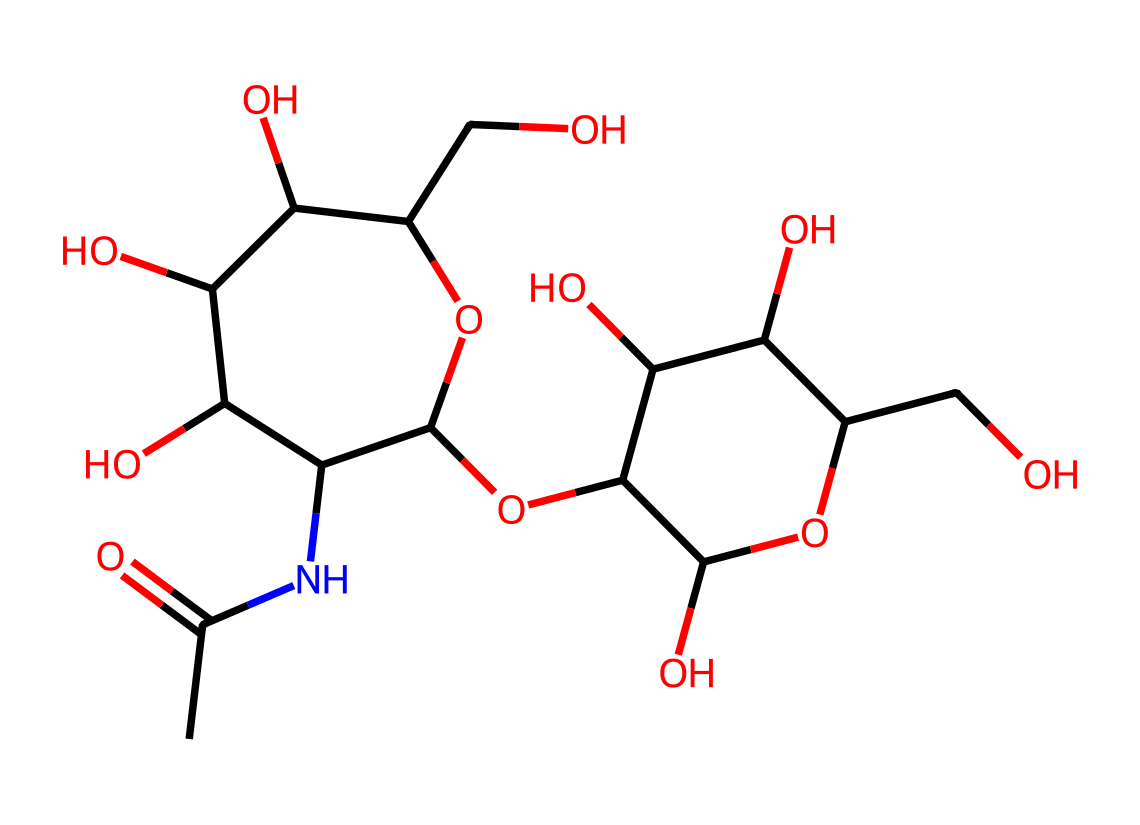What is the molecular formula of hyaluronic acid? To determine the molecular formula, we need to analyze the SMILES structure for the types and quantities of each atom present. In this case, C (carbon), H (hydrogen), O (oxygen), and N (nitrogen) can be counted from the SMILES representation. There are a total of 24 carbon atoms, 39 hydrogen atoms, 29 oxygen atoms, and 1 nitrogen atom. Thus, the molecular formula is C24H39N1O29.
Answer: C24H39N1O29 How many oxygen atoms are in the structure? By closely examining the SMILES string, we can identify each oxygen atom present. The structure contains 29 oxygen atoms as part of various functional groups, including hydroxyl (-OH) and ether groups. Counting each occurrence gives the total count.
Answer: 29 What functional groups are present in hyaluronic acid? The structural representation indicates several functional groups such as hydroxyl (-OH), amine (-NH), and carboxyl (-COOH) groups. These can be identified based on the where the oxygen and nitrogen appear in the structure. These groups contribute to the molecule's properties and functions.
Answer: hydroxyl, amine, carboxyl What type of chemical is hyaluronic acid primarily classified as? Hyaluronic acid is classified as a glycosaminoglycan, which is a type of polysaccharide. It is characterized by its long chains of disaccharides and is essential in connective tissues. This classification can be concluded from its repeating sugar units visible in its structure.
Answer: glycosaminoglycan How does the presence of nitrogen influence the properties of hyaluronic acid? The nitrogen atom in the structure suggests the presence of amine functionality. This can influence the binding properties of the molecule, allowing it to interact with other substances in biological systems, contributing to its moisturizing and plumping effects in skincare products.
Answer: enhances binding and moisturizing properties What is the significance of the repeating units in hyaluronic acid? The structure reveals distinct repeating disaccharide units. These repeating units contribute to hyaluronic acid's high molecular weight and ability to retain water, which is crucial for its role in hydrating and cushioning skin and other tissues.
Answer: water retention and hydration How is the structure of hyaluronic acid related to its function in skincare? The large size and polar nature of hyaluronic acid allow it to attract and hold onto water molecules, making it an excellent moisturizer. The specific arrangement of its functional groups enhances hydration and improves skin elasticity, which is vital for skincare products’ effectiveness.
Answer: enhances hydration and skin elasticity 